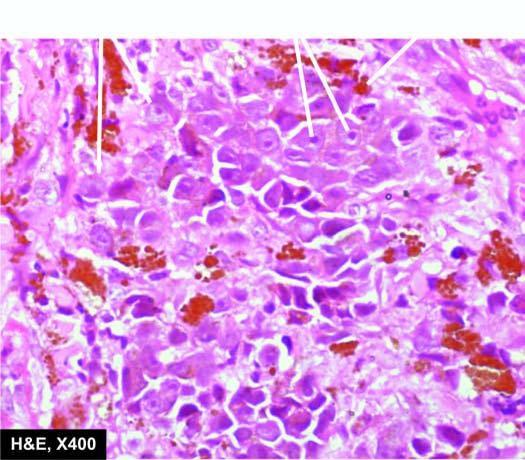re the tumour cells epithelioid in appearance having prominent nucleoli and contain black finely granular melanin pigment in the cytoplasm?
Answer the question using a single word or phrase. Yes 